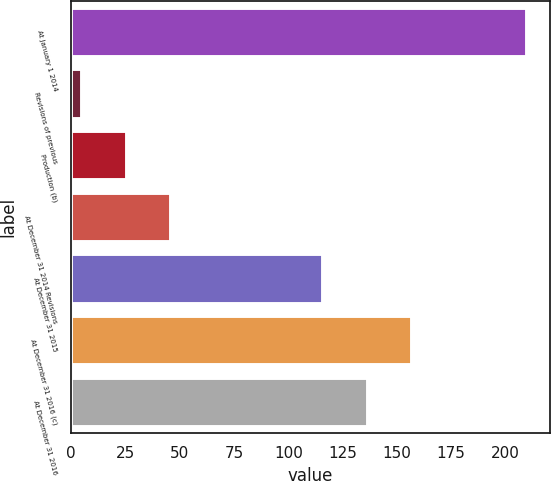<chart> <loc_0><loc_0><loc_500><loc_500><bar_chart><fcel>At January 1 2014<fcel>Revisions of previous<fcel>Production (b)<fcel>At December 31 2014 Revisions<fcel>At December 31 2015<fcel>At December 31 2016 (c)<fcel>At December 31 2016<nl><fcel>210<fcel>5<fcel>25.5<fcel>46<fcel>116<fcel>157<fcel>136.5<nl></chart> 